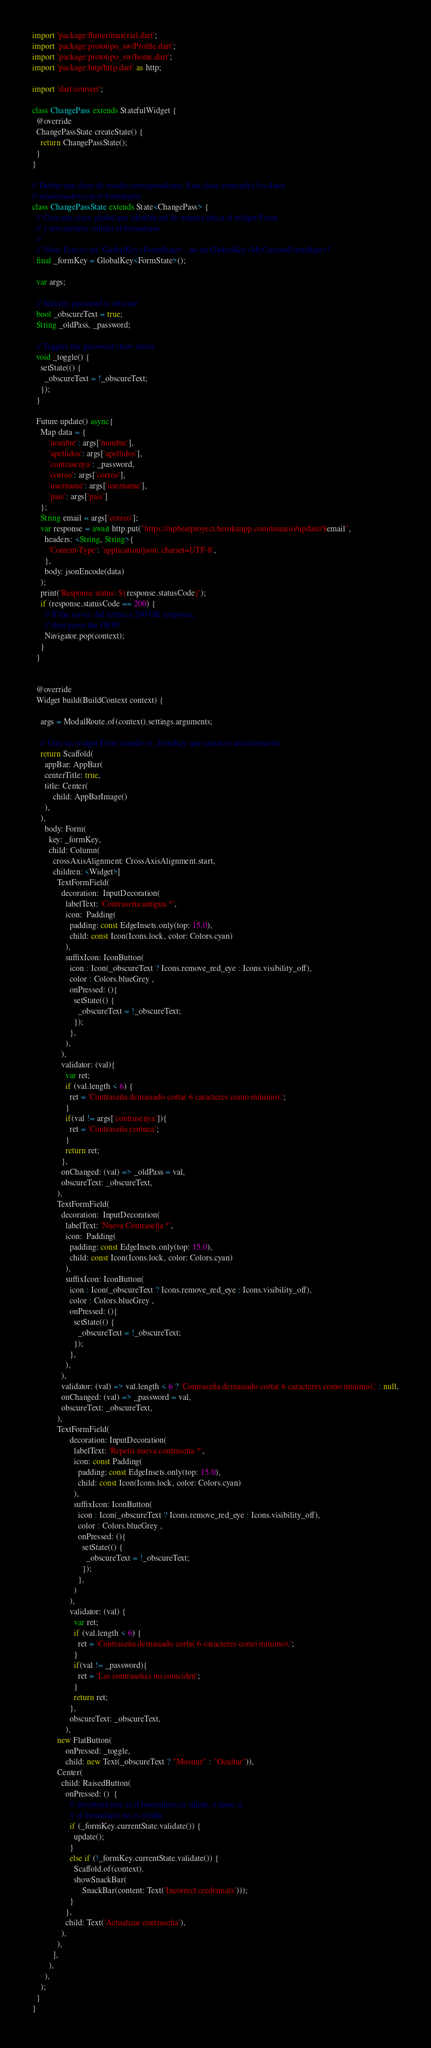<code> <loc_0><loc_0><loc_500><loc_500><_Dart_>import 'package:flutter/material.dart';
import 'package:prototipo_sw/Profile.dart';
import 'package:prototipo_sw/home.dart';
import 'package:http/http.dart' as http;

import 'dart:convert';

class ChangePass extends StatefulWidget {
  @override
  ChangePassState createState() {
    return ChangePassState();
  }
}

// Define una clase de estado correspondiente. Esta clase contendrá los datos
// relacionados con el formulario.
class ChangePassState extends State<ChangePass> {
  // Crea una clave global que identificará de manera única el widget Form
  // y nos permita validar el formulario
  //
  // Nota: Esto es un `GlobalKey<FormState>`, no un GlobalKey<MyCustomFormState>!
  final _formKey = GlobalKey<FormState>();

  var args;

  // Initially password is obscure
  bool _obscureText = true;
  String _oldPass, _password;

  // Toggles the password show status
  void _toggle() {
    setState(() {
      _obscureText = !_obscureText;
    });
  }

  Future update() async{
    Map data = {
        'nombre': args['nombre'],
        'apellidos': args['apellidos'],
        'contrasenya': _password,
        'correo': args['correo'],
        'username': args['username'],
        'pais': args['pais']
    };
    String email = args['correo'];
    var response = await http.put("https://upbeatproyect.herokuapp.com/usuario/update/$email",  
      headers: <String, String>{
        'Content-Type': 'application/json; charset=UTF-8',
      },
      body: jsonEncode(data)
    );
    print('Response status: ${response.statusCode}');
    if (response.statusCode == 200) {
      // If the server did return a 200 OK response,
      // then parse the JSON
      Navigator.pop(context);
    }
  }


  @override
  Widget build(BuildContext context) {

    args = ModalRoute.of(context).settings.arguments;
   
    // Cree un widget Form usando el _formKey que creamos anteriormente
    return Scaffold(
      appBar: AppBar(
      centerTitle: true,
      title: Center(
          child: AppBarImage()
      ),
    ),
      body: Form(
        key: _formKey,
        child: Column(
          crossAxisAlignment: CrossAxisAlignment.start,
          children: <Widget>[
            TextFormField(
              decoration:  InputDecoration(
                labelText: 'Contraseña antigua *',
                icon:  Padding(
                  padding: const EdgeInsets.only(top: 15.0),
                  child: const Icon(Icons.lock, color: Colors.cyan)
                ),
                suffixIcon: IconButton(
                  icon : Icon(_obscureText ? Icons.remove_red_eye : Icons.visibility_off),
                  color : Colors.blueGrey ,
                  onPressed: (){
                    setState(() {
                      _obscureText = !_obscureText;
                    });
                  },
                ),
              ),
              validator: (val){
                var ret;
                if (val.length < 6) {
                  ret = 'Contraseña demasiado corta( 6 caracteres como mínimo).';
                } 
                if(val != args['contrasenya']){
                  ret = 'Contraseña errónea';
                }
                return ret;
              },
              onChanged: (val) => _oldPass = val,
              obscureText: _obscureText,
            ),
            TextFormField(
              decoration:  InputDecoration(
                labelText: 'Nueva Contraseña *',
                icon:  Padding(
                  padding: const EdgeInsets.only(top: 15.0),
                  child: const Icon(Icons.lock, color: Colors.cyan)
                ),
                suffixIcon: IconButton(
                  icon : Icon(_obscureText ? Icons.remove_red_eye : Icons.visibility_off),
                  color : Colors.blueGrey ,
                  onPressed: (){
                    setState(() {
                      _obscureText = !_obscureText;
                    });
                  },
                ),
              ),
              validator: (val) => val.length < 6 ? 'Contraseña demasiado corta( 6 caracteres como mínimo).' : null,
              onChanged: (val) => _password = val,
              obscureText: _obscureText,
            ),
            TextFormField(
                  decoration: InputDecoration(
                    labelText: 'Repetir nueva contraseña *',
                    icon: const Padding(
                      padding: const EdgeInsets.only(top: 15.0),
                      child: const Icon(Icons.lock, color: Colors.cyan)
                    ),
                    suffixIcon: IconButton(
                      icon : Icon(_obscureText ? Icons.remove_red_eye : Icons.visibility_off),
                      color : Colors.blueGrey ,
                      onPressed: (){
                        setState(() {
                          _obscureText = !_obscureText;
                        });
                      },
                    )
                  ),
                  validator: (val) {
                    var ret;
                    if (val.length < 6) {
                      ret = 'Contraseña demasiado corta( 6 caracteres como mínimo).';
                    } 
                    if(val != _password){
                      ret = 'Las contraseñas no coinciden';
                    }
                    return ret;
                  },
                  obscureText: _obscureText,
                ),
            new FlatButton(
                onPressed: _toggle,
                child: new Text(_obscureText ? "Mostrar" : "Ocultar")),
            Center(
              child: RaisedButton(
                onPressed: ()  {
                  // devolverá true si el formulario es válido, o falso si
                  // el formulario no es válido.
                  if (_formKey.currentState.validate()) {
                    update();
                  }
                  else if (!_formKey.currentState.validate()) {
                    Scaffold.of(context).
                    showSnackBar(
                        SnackBar(content: Text('Incorrect credentials')));
                  }
                },
                child: Text('Actualizar contraseña'),
              ),
            ),
          ],
        ),
      ),
    );
  }
}</code> 